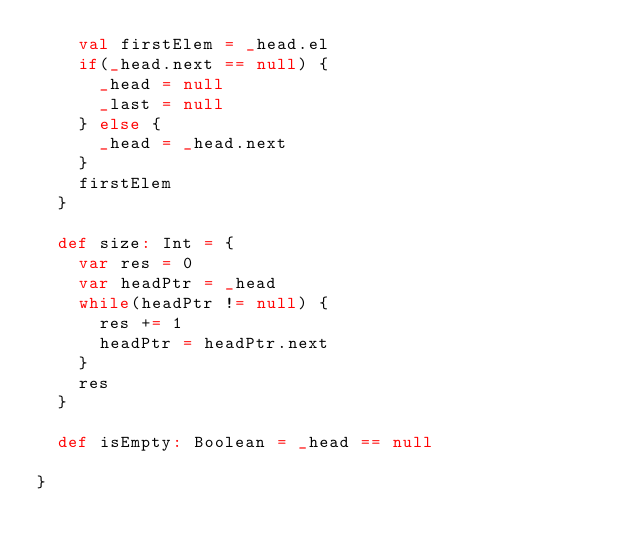Convert code to text. <code><loc_0><loc_0><loc_500><loc_500><_Scala_>    val firstElem = _head.el
    if(_head.next == null) {
      _head = null
      _last = null
    } else {
      _head = _head.next
    }
    firstElem
  }

  def size: Int = {
    var res = 0
    var headPtr = _head
    while(headPtr != null) {
      res += 1
      headPtr = headPtr.next
    }
    res
  }

  def isEmpty: Boolean = _head == null

}
</code> 